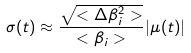Convert formula to latex. <formula><loc_0><loc_0><loc_500><loc_500>\sigma ( t ) \approx \frac { \sqrt { < \Delta \beta _ { i } ^ { 2 } > } } { < \beta _ { i } > } | \mu ( t ) |</formula> 